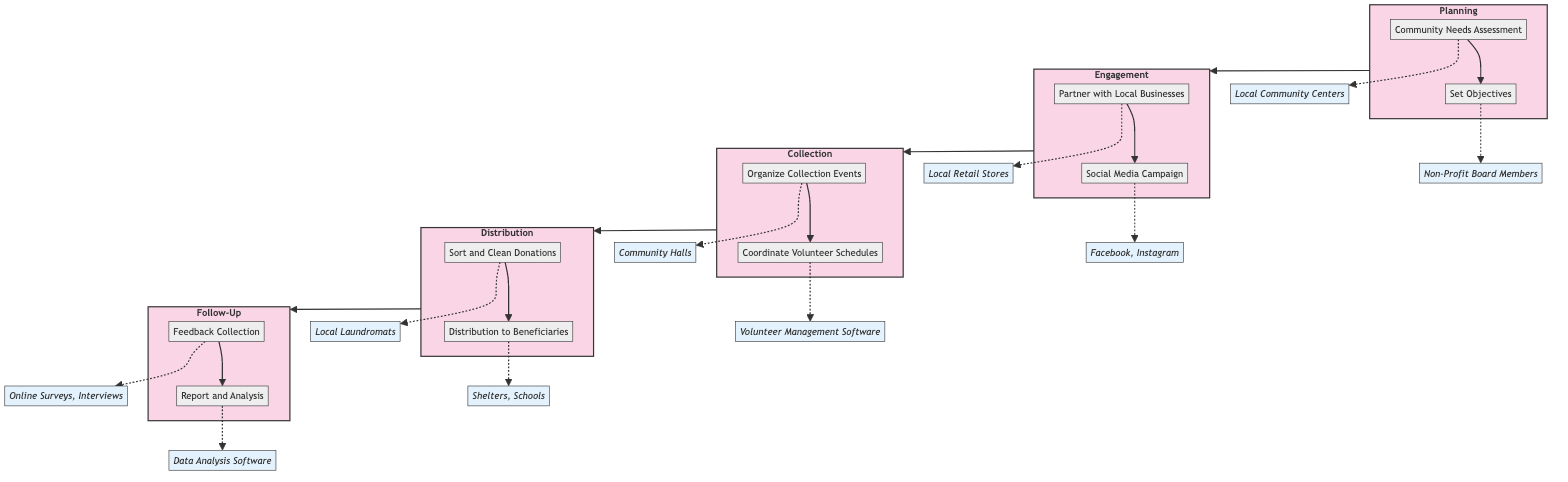What's the first task in the Planning stage? The first task listed in the Planning stage is "Community Needs Assessment." It's located at the top of the Planning stage node in the diagram.
Answer: Community Needs Assessment How many tasks are there in the Engagement stage? The Engagement stage contains two tasks: "Partner with Local Businesses" and "Social Media Campaign." Count the tasks in this stage to find the answer.
Answer: 2 What is the last stage in the Clinical Pathway? The last stage in the Clinical Pathway is "Follow-Up," as it is the terminal stage that follows Distribution.
Answer: Follow-Up Which entities are involved in sorting and cleaning donations? The entity mentioned in the task "Sort and Clean Donations" is "Local Laundromats." This is explicitly stated in the diagram associated with that task.
Answer: Local Laundromats What is the relationship between Collection and Distribution stages? The diagram shows a direct flow from the Collection stage to the Distribution stage, indicating that after collecting donations, they are sorted and then distributed.
Answer: Direct flow Which task is associated with Online Surveys and Interviews? The task "Feedback Collection" is associated with the entities "Online Surveys, Interviews," which is reflected in the Follow-Up stage of the diagram.
Answer: Feedback Collection What is the objective of the Set Objectives task? The task "Set Objectives" aims to define clear objectives for the clothing donation campaign, including volume and target demographics, as described in the Planning stage.
Answer: Define clear objectives How many total stages are there in the Clinical Pathway? There are five distinct stages in the Clinical Pathway: Planning, Engagement, Collection, Distribution, and Follow-Up. Count each of them to get the total.
Answer: 5 Which task involves coordinating volunteers? The task that involves coordinating volunteers is "Coordinate Volunteer Schedules," as shown in the Collection stage of the diagram.
Answer: Coordinate Volunteer Schedules 